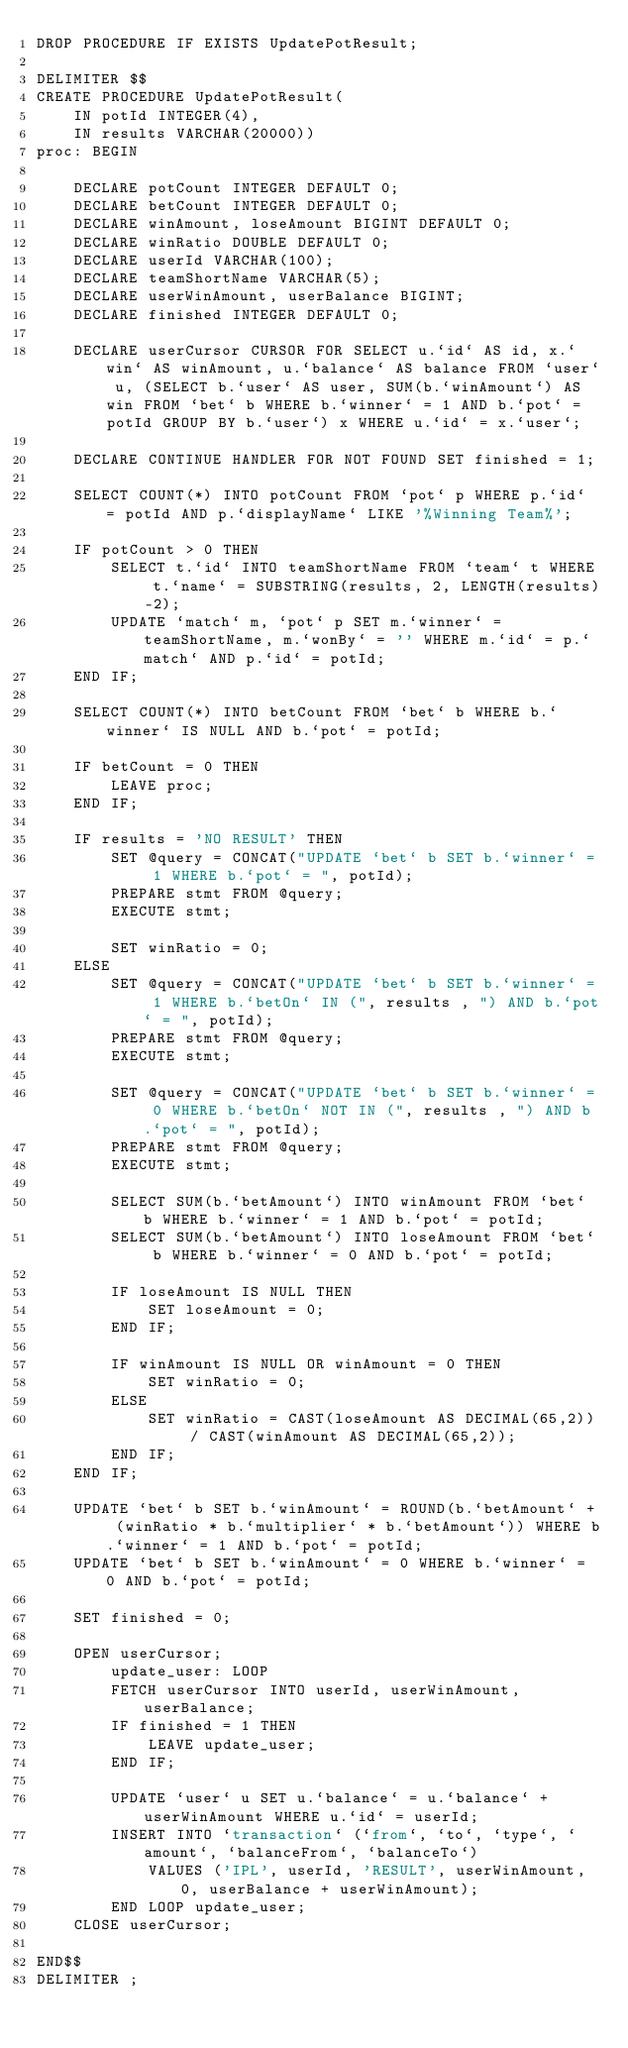<code> <loc_0><loc_0><loc_500><loc_500><_SQL_>DROP PROCEDURE IF EXISTS UpdatePotResult;

DELIMITER $$
CREATE PROCEDURE UpdatePotResult(
    IN potId INTEGER(4),
    IN results VARCHAR(20000))
proc: BEGIN
    
    DECLARE potCount INTEGER DEFAULT 0;
    DECLARE betCount INTEGER DEFAULT 0;
    DECLARE winAmount, loseAmount BIGINT DEFAULT 0;
    DECLARE winRatio DOUBLE DEFAULT 0;
    DECLARE userId VARCHAR(100);
    DECLARE teamShortName VARCHAR(5);
    DECLARE userWinAmount, userBalance BIGINT;
    DECLARE finished INTEGER DEFAULT 0;
    
    DECLARE userCursor CURSOR FOR SELECT u.`id` AS id, x.`win` AS winAmount, u.`balance` AS balance FROM `user` u, (SELECT b.`user` AS user, SUM(b.`winAmount`) AS win FROM `bet` b WHERE b.`winner` = 1 AND b.`pot` = potId GROUP BY b.`user`) x WHERE u.`id` = x.`user`;
    
    DECLARE CONTINUE HANDLER FOR NOT FOUND SET finished = 1;
    
    SELECT COUNT(*) INTO potCount FROM `pot` p WHERE p.`id` = potId AND p.`displayName` LIKE '%Winning Team%';
    
    IF potCount > 0 THEN
        SELECT t.`id` INTO teamShortName FROM `team` t WHERE t.`name` = SUBSTRING(results, 2, LENGTH(results)-2);
        UPDATE `match` m, `pot` p SET m.`winner` = teamShortName, m.`wonBy` = '' WHERE m.`id` = p.`match` AND p.`id` = potId;
    END IF;
    
    SELECT COUNT(*) INTO betCount FROM `bet` b WHERE b.`winner` IS NULL AND b.`pot` = potId;
    
    IF betCount = 0 THEN
        LEAVE proc;
    END IF;
    
    IF results = 'NO RESULT' THEN
        SET @query = CONCAT("UPDATE `bet` b SET b.`winner` = 1 WHERE b.`pot` = ", potId);
        PREPARE stmt FROM @query;
        EXECUTE stmt;
        
        SET winRatio = 0;
    ELSE
        SET @query = CONCAT("UPDATE `bet` b SET b.`winner` = 1 WHERE b.`betOn` IN (", results , ") AND b.`pot` = ", potId);
        PREPARE stmt FROM @query;
        EXECUTE stmt;

        SET @query = CONCAT("UPDATE `bet` b SET b.`winner` = 0 WHERE b.`betOn` NOT IN (", results , ") AND b.`pot` = ", potId);
        PREPARE stmt FROM @query;
        EXECUTE stmt;

        SELECT SUM(b.`betAmount`) INTO winAmount FROM `bet` b WHERE b.`winner` = 1 AND b.`pot` = potId;
        SELECT SUM(b.`betAmount`) INTO loseAmount FROM `bet` b WHERE b.`winner` = 0 AND b.`pot` = potId;

        IF loseAmount IS NULL THEN
            SET loseAmount = 0;
        END IF;

        IF winAmount IS NULL OR winAmount = 0 THEN
            SET winRatio = 0;
        ELSE
            SET winRatio = CAST(loseAmount AS DECIMAL(65,2)) / CAST(winAmount AS DECIMAL(65,2));
        END IF;
    END IF;

    UPDATE `bet` b SET b.`winAmount` = ROUND(b.`betAmount` + (winRatio * b.`multiplier` * b.`betAmount`)) WHERE b.`winner` = 1 AND b.`pot` = potId;
    UPDATE `bet` b SET b.`winAmount` = 0 WHERE b.`winner` = 0 AND b.`pot` = potId;

    SET finished = 0;
    
    OPEN userCursor;
        update_user: LOOP
        FETCH userCursor INTO userId, userWinAmount, userBalance;
        IF finished = 1 THEN
            LEAVE update_user;
        END IF;

        UPDATE `user` u SET u.`balance` = u.`balance` + userWinAmount WHERE u.`id` = userId;
        INSERT INTO `transaction` (`from`, `to`, `type`, `amount`, `balanceFrom`, `balanceTo`)
            VALUES ('IPL', userId, 'RESULT', userWinAmount, 0, userBalance + userWinAmount);
        END LOOP update_user;
    CLOSE userCursor;

END$$
DELIMITER ;
</code> 